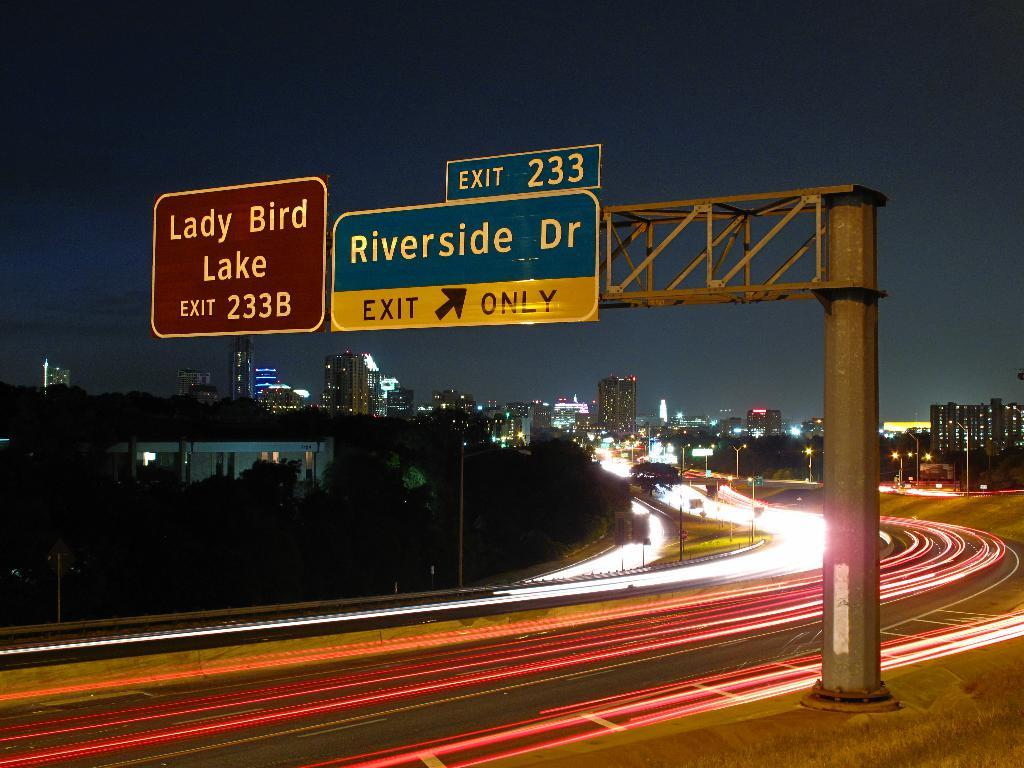Provide a one-sentence caption for the provided image. A timelapse of a freeway with cars shown just as trails of lights, with a large exit sign to Riverside Drive. 